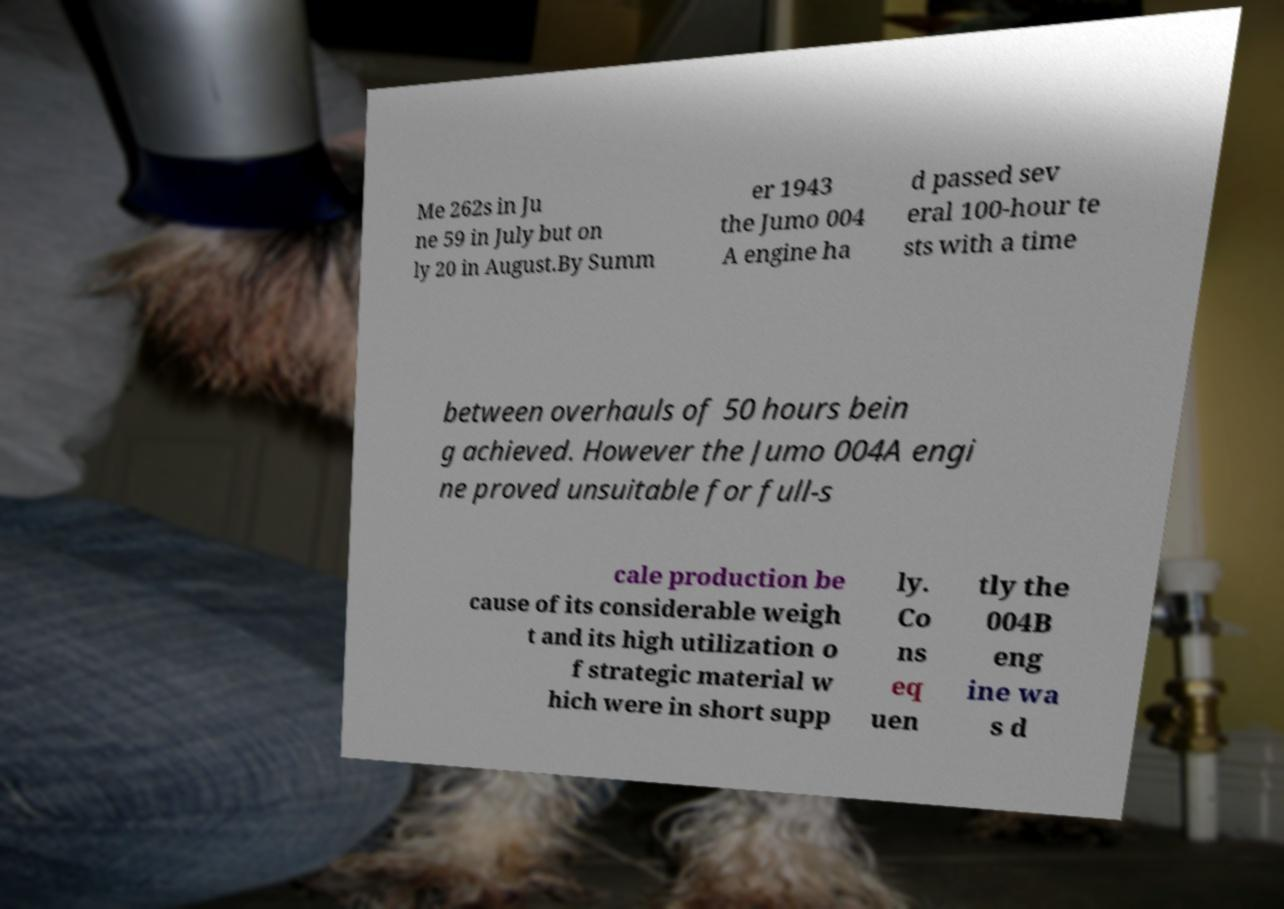Can you accurately transcribe the text from the provided image for me? Me 262s in Ju ne 59 in July but on ly 20 in August.By Summ er 1943 the Jumo 004 A engine ha d passed sev eral 100-hour te sts with a time between overhauls of 50 hours bein g achieved. However the Jumo 004A engi ne proved unsuitable for full-s cale production be cause of its considerable weigh t and its high utilization o f strategic material w hich were in short supp ly. Co ns eq uen tly the 004B eng ine wa s d 